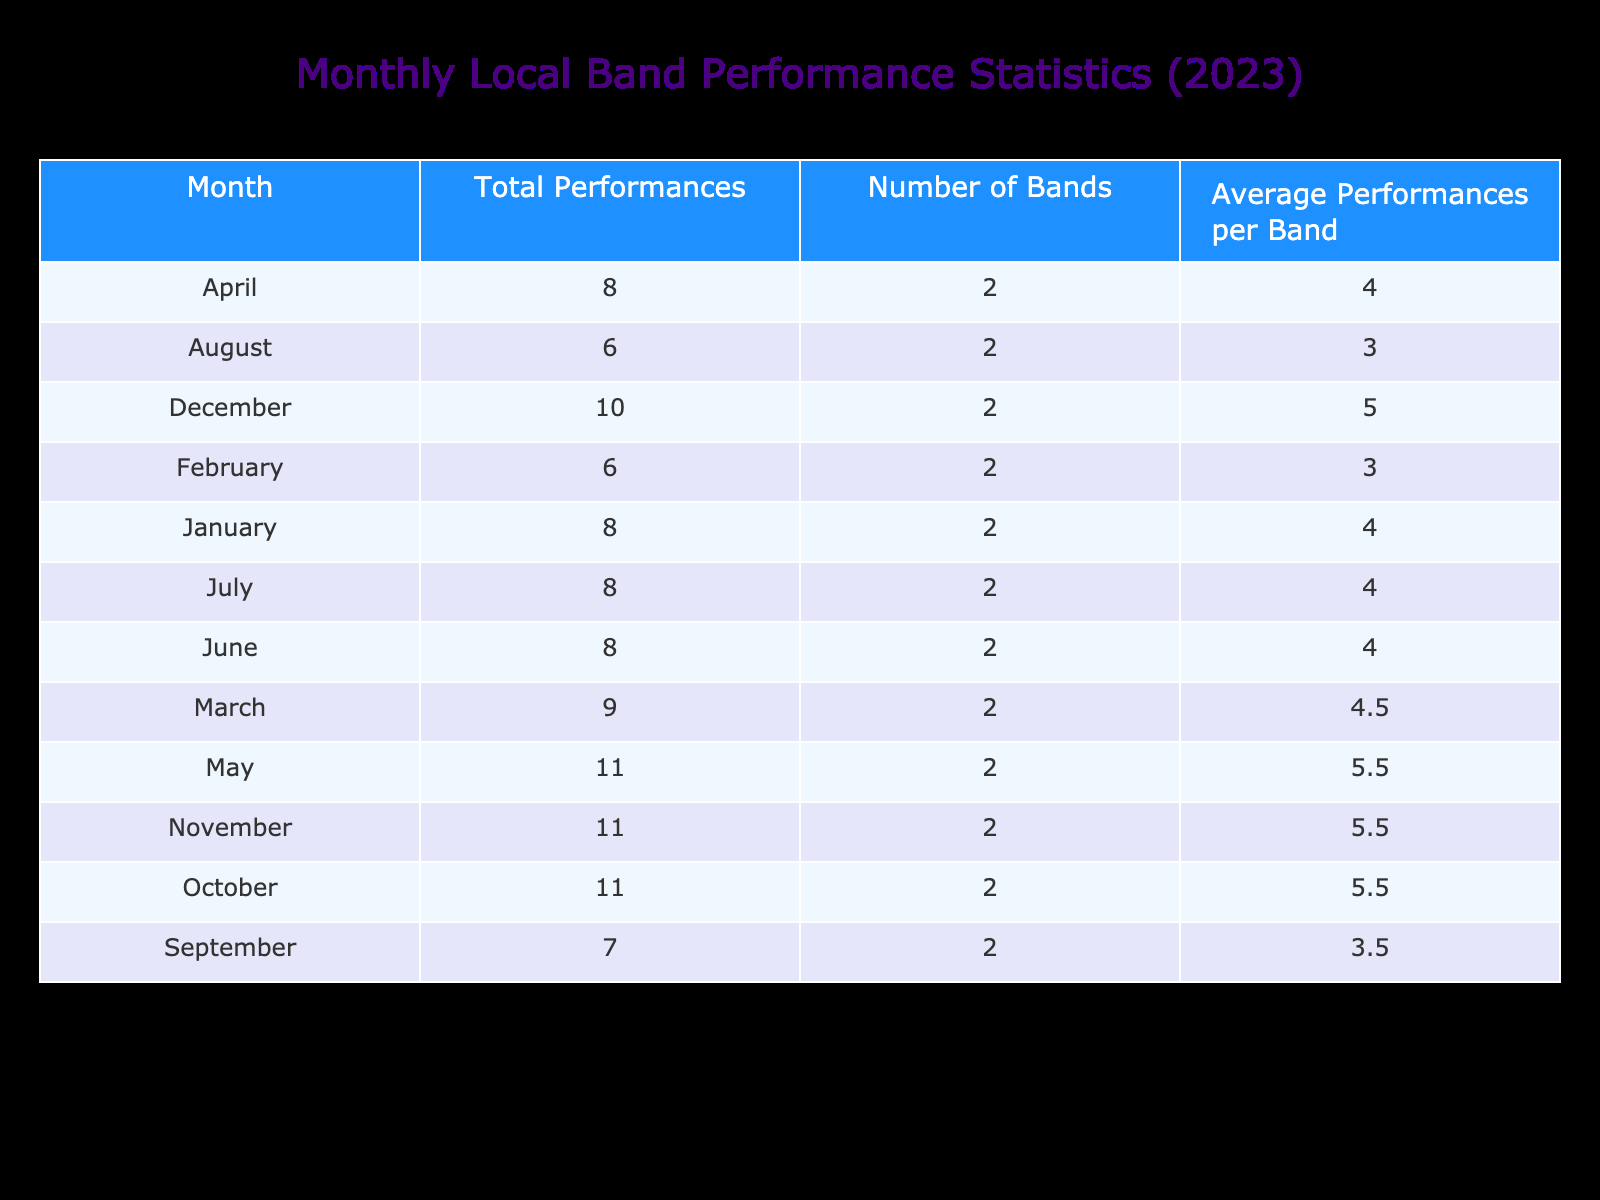What month had the highest total performances? To find the month with the highest total performances, review the 'Total Performances' column and look for the maximum value. In the table, December has the highest total performances of 10.
Answer: December Which band performed the most in August? In August, the table lists "Electric Skies" with 4 performances and "Lost in Harmony" with 2 performances. Therefore, "Electric Skies" performed the most.
Answer: Electric Skies What is the average number of performances per band in September? In September, there were 3 bands listed with a total of 7 performances (3 from Backyard Boogie and 4 from Summer Sunset). The average is calculated as 7 performances / 2 bands = 3.5.
Answer: 3.5 Did any month have an equal number of performances from different bands? Yes, in both January and April, "The Midnight Echo" and "Soulful Rhythms" together had 8 total performances. Hence, January had equal performances from 2 bands, as did April.
Answer: Yes How many bands were active in June? In June, there are 2 bands: "Unplugged Sessions" and "The Urban Folk." This information can be easily found by counting the number of unique band names listed for the month of June in the table.
Answer: 2 Which month had the least number of performances overall? By checking the 'Total Performances' column for each month, we find that February had the least total performances of 6 (4 from Electric Vibes and 2 from The Groove Seekers).
Answer: February What is the total number of performances across all months? To find the total performances, you need to sum up all the values in the 'Total Performances' column for each month: 5 + 3 + 6 + 8 + 8 + 5 + 4 + 10 + 7 + 4 + 8 + 2 = 68 performances in total. So, the total number of performances is 68.
Answer: 68 Is there a month with more than 8 total performances? Yes, in December, the total performances amount to 10. Therefore, there is indeed at least one month with more than 8 performances.
Answer: Yes Which genre had the maximum average performances per band? To determine the genre with the highest average performances, first calculate average performances for each genre by adding the performances for bands of that genre and dividing by the number of bands in that genre. The calculations show that Acoustic has the max average at 6 performances due to the contributions from bands in that genre for several months.
Answer: Acoustic 